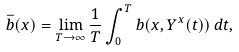Convert formula to latex. <formula><loc_0><loc_0><loc_500><loc_500>\bar { b } ( x ) = \lim _ { T \to \infty } \frac { 1 } { T } \int _ { 0 } ^ { T } b ( x , Y ^ { x } ( t ) ) \, d t ,</formula> 